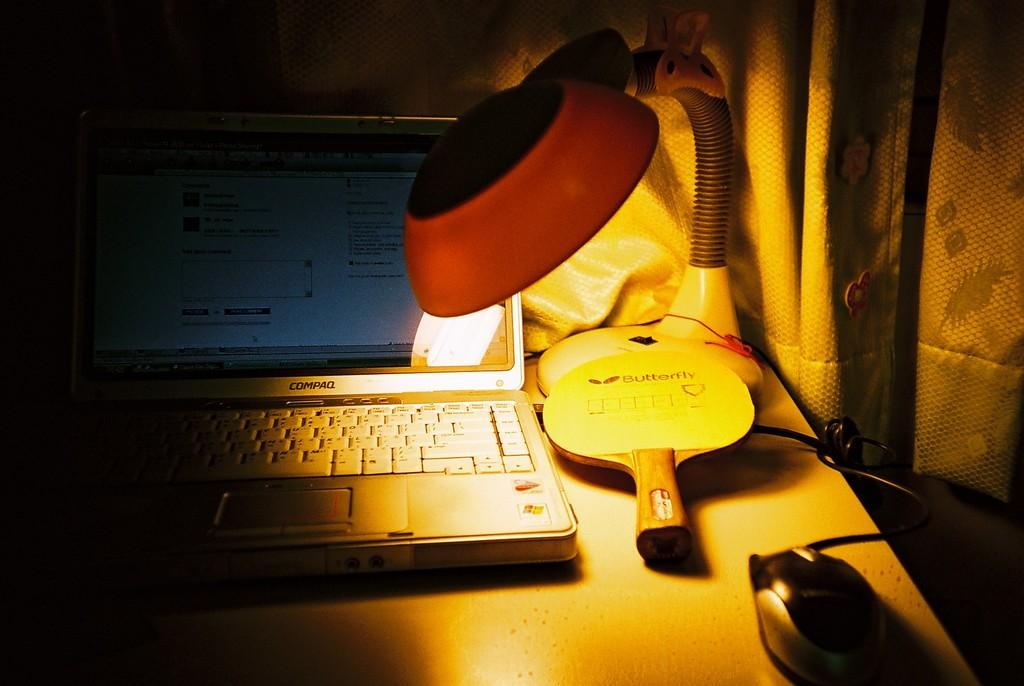What is on the table in the image? There is a bat, a lamp, a laptop, a mouse, and a cable on the table in the image. What type of light source is on the table? There is a lamp on the table. What electronic device is on the table? There is a laptop on the table. What is the purpose of the mouse on the table? The mouse is likely used as a computer mouse for the laptop. What is the cable connected to? The cable is connected to the laptop. What can be seen in the background of the image? There is a curtain in the background of the image. Can you see a porter carrying a suitcase in the image? There is no porter carrying a suitcase in the image. Is there a squirrel sitting on the laptop in the image? There is no squirrel present in the image. 